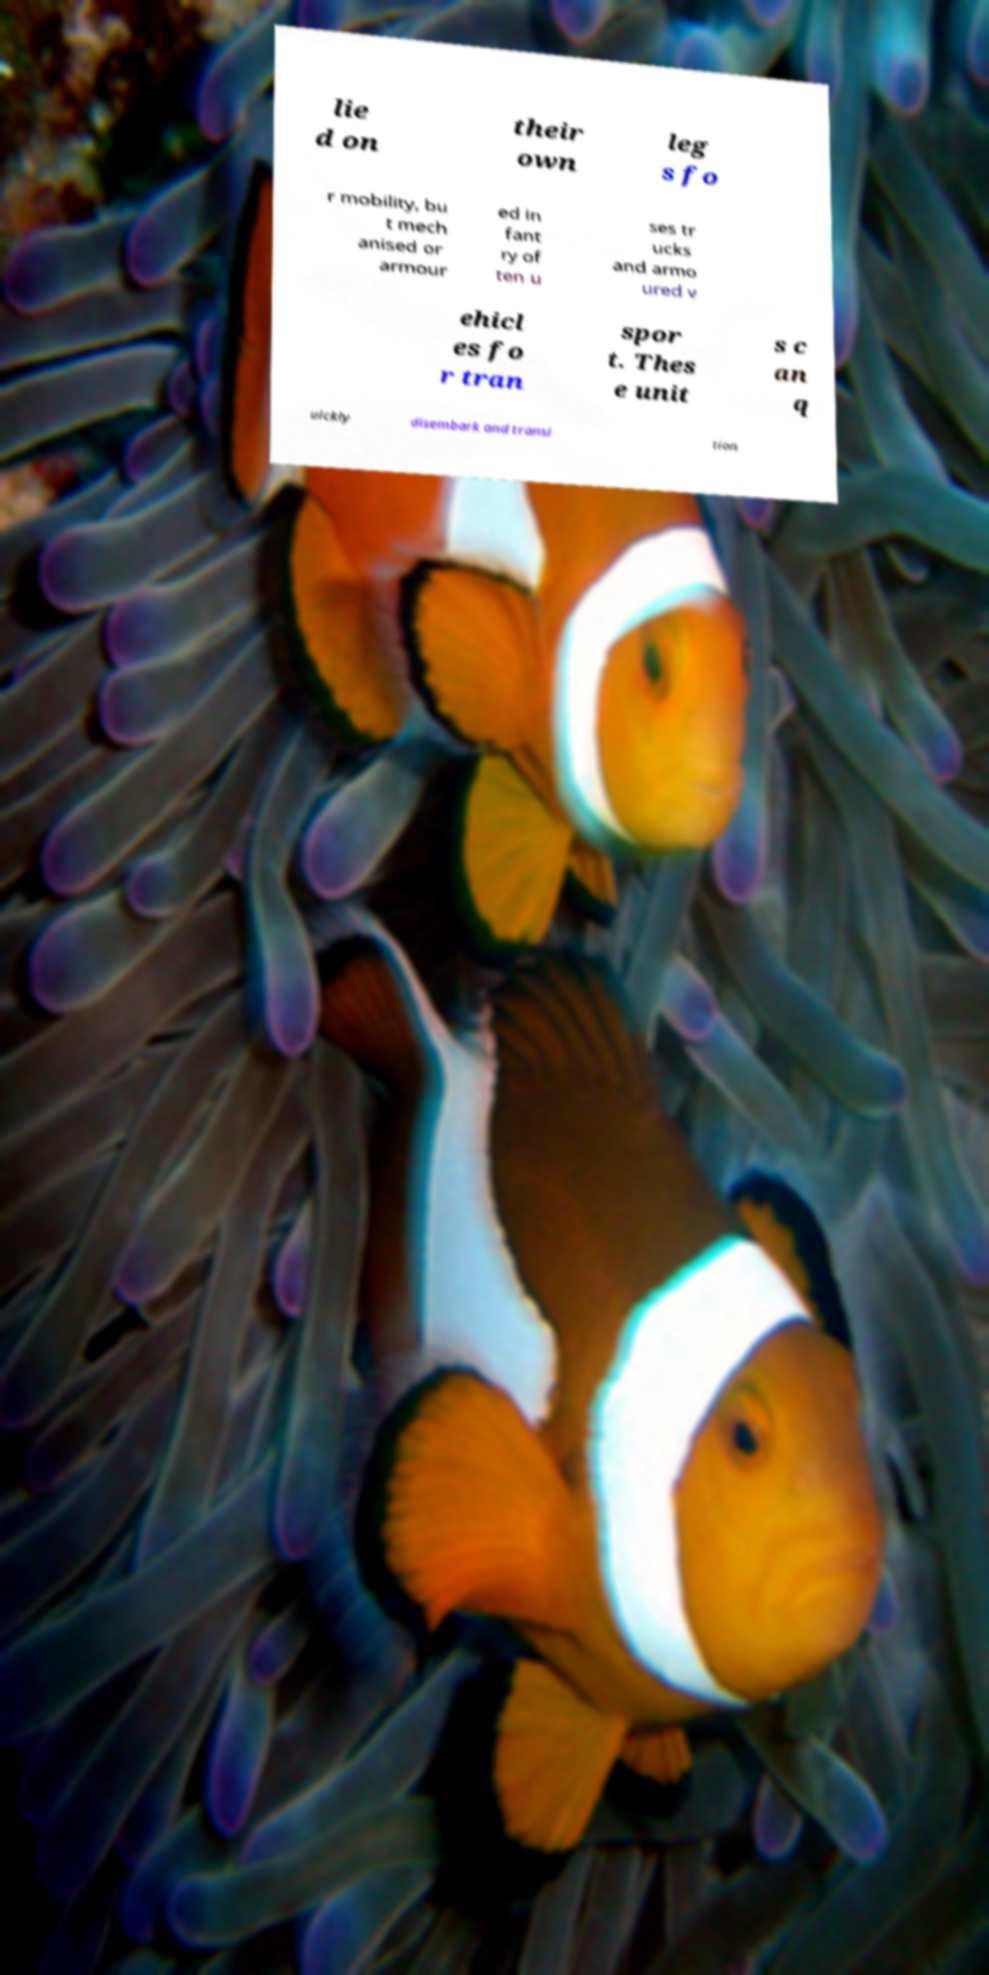For documentation purposes, I need the text within this image transcribed. Could you provide that? lie d on their own leg s fo r mobility, bu t mech anised or armour ed in fant ry of ten u ses tr ucks and armo ured v ehicl es fo r tran spor t. Thes e unit s c an q uickly disembark and transi tion 